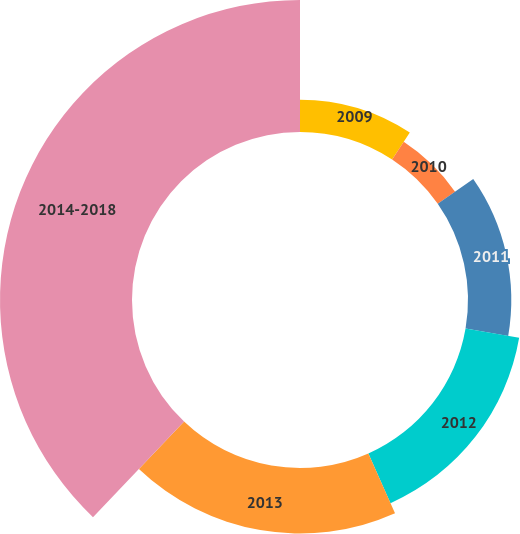Convert chart to OTSL. <chart><loc_0><loc_0><loc_500><loc_500><pie_chart><fcel>2009<fcel>2010<fcel>2011<fcel>2012<fcel>2013<fcel>2014-2018<nl><fcel>9.24%<fcel>6.06%<fcel>12.42%<fcel>15.61%<fcel>18.79%<fcel>37.88%<nl></chart> 